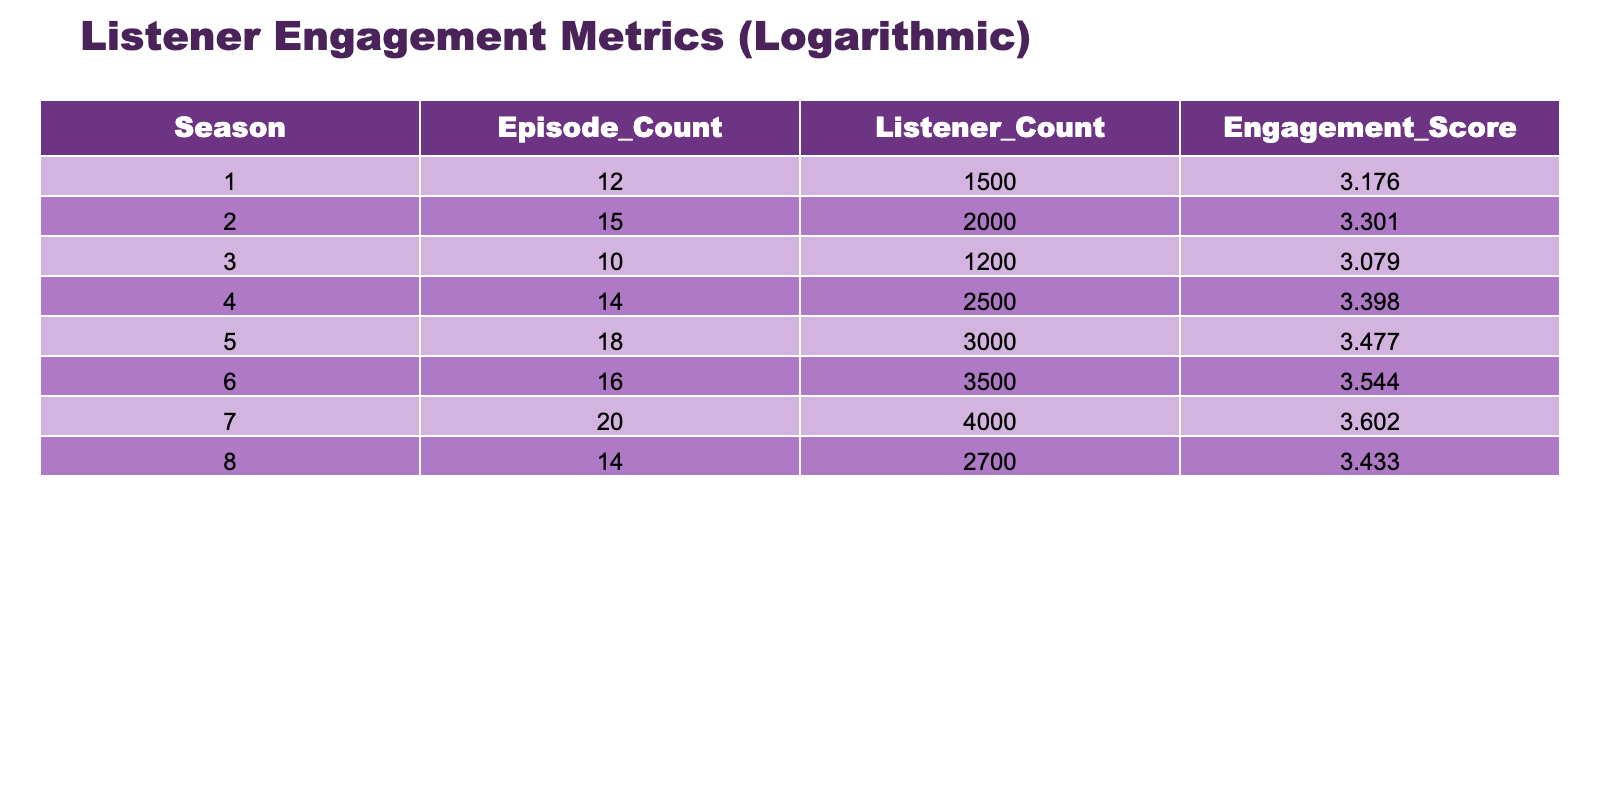What is the engagement score for Season 5? The engagement score is found in the row corresponding to Season 5, which has a value of 3.477 in the Engagement Score column.
Answer: 3.477 Which season had the highest listener count? By examining the Listener Count column, Season 6 has the highest value of 3500 listeners, making it the season with the most listeners.
Answer: Season 6 What is the average engagement score across all seasons? To find the average engagement score, sum all engagement scores (3.176 + 3.301 + 3.079 + 3.398 + 3.477 + 3.544 + 3.602 + 3.433 = 27.510) and divide by the number of seasons (8). The average engagement score is 27.510 / 8 = 3.439.
Answer: 3.439 Is the engagement score for Season 3 greater than 3? Checking the Engagement Score for Season 3, which is 3.079, confirms it is less than 3, so the statement is false.
Answer: No Which season experienced an increase in listener count from the previous season? By comparing the Listener Counts: Season 1 to Season 2 (1500 to 2000), Season 2 to Season 3 (2000 to 1200), Season 3 to Season 4 (1200 to 2500), Season 4 to Season 5 (2500 to 3000), Season 5 to Season 6 (3000 to 3500), Season 6 to Season 7 (3500 to 4000), and Season 7 to Season 8 (4000 to 2700), the increases occur from Season 1 to 2, 3 to 4, 4 to 5, 5 to 6, and 6 to 7. So, Seasons 1, 2, 4, 5, 6, and 7 experienced increases in listener count.
Answer: Seasons 1, 2, 4, 5, 6, and 7 What is the difference in engagement scores between Season 4 and Season 2? The engagement score for Season 4 is 3.398, and for Season 2 it is 3.301. The difference is calculated as 3.398 - 3.301 = 0.097.
Answer: 0.097 